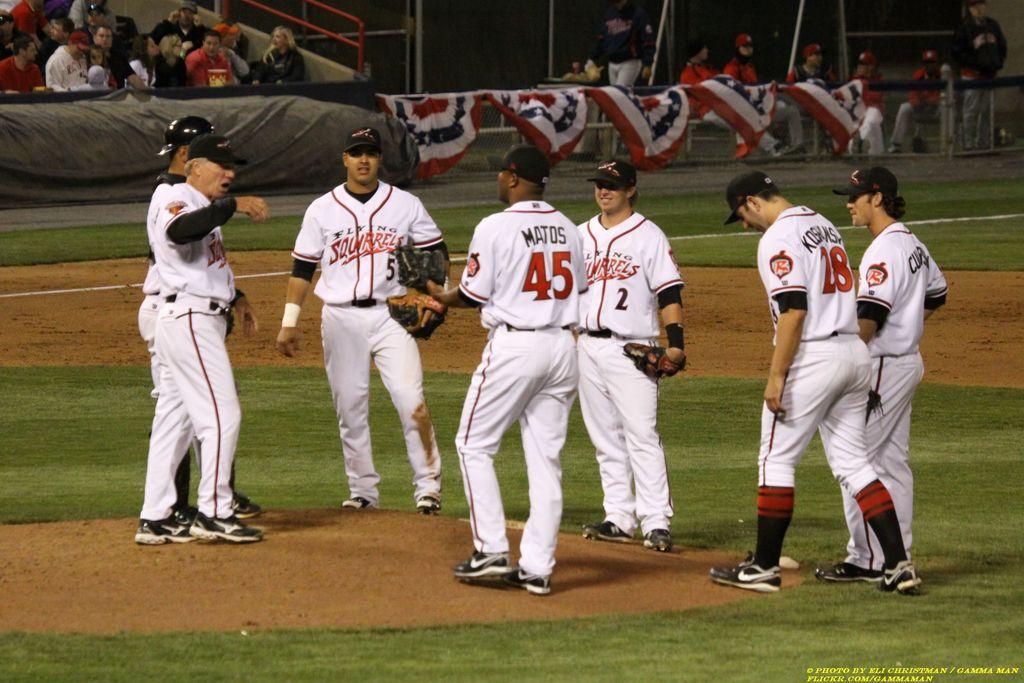What number is matos?
Give a very brief answer. 45. 